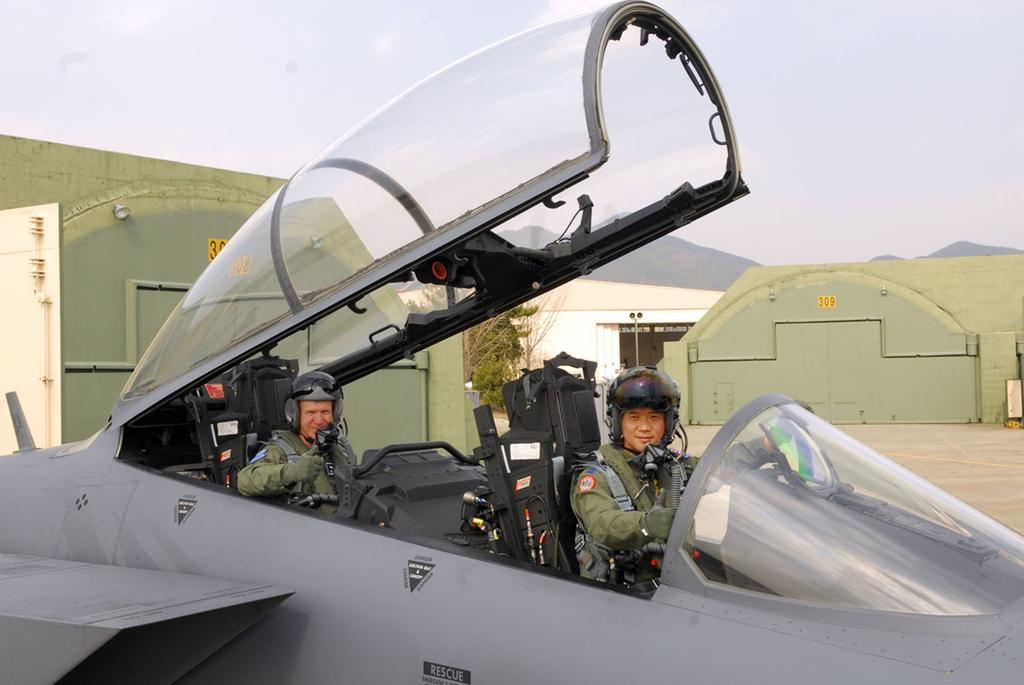<image>
Present a compact description of the photo's key features. A military jet infront of a hangar with the number 309 on it 